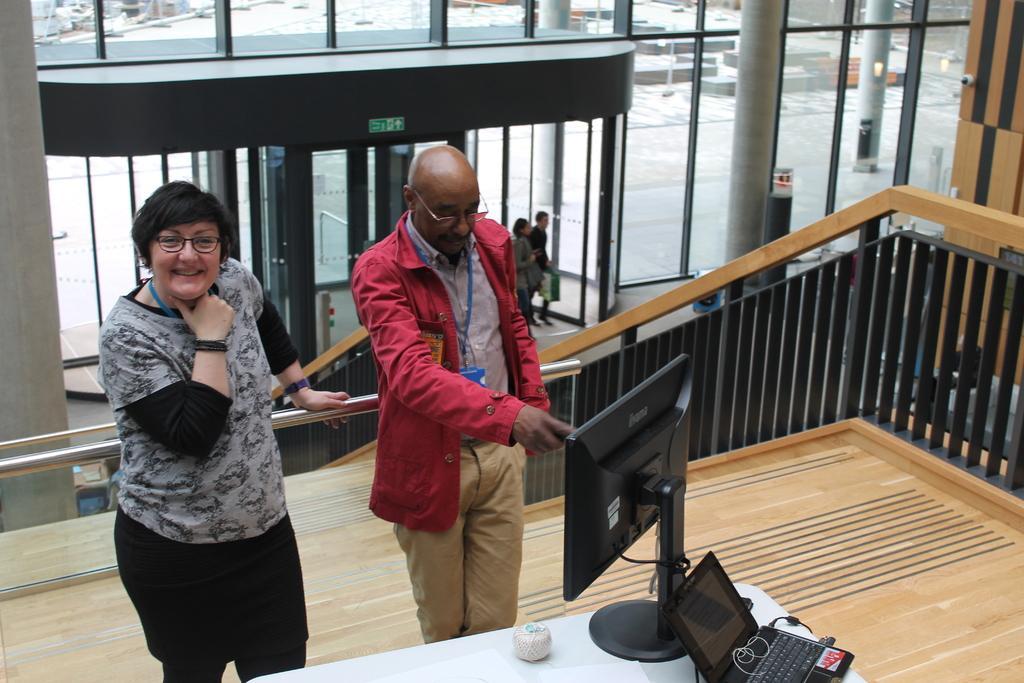Please provide a concise description of this image. In the picture we can see a man and a woman standing on the floor near the desk and on it we can see a monitor and behind it, we can see a laptop which is black in color and a man is showing something in the monitor and beside them, we can see a railing and in the background we can see glass wall and near it we can see two people are standing. 